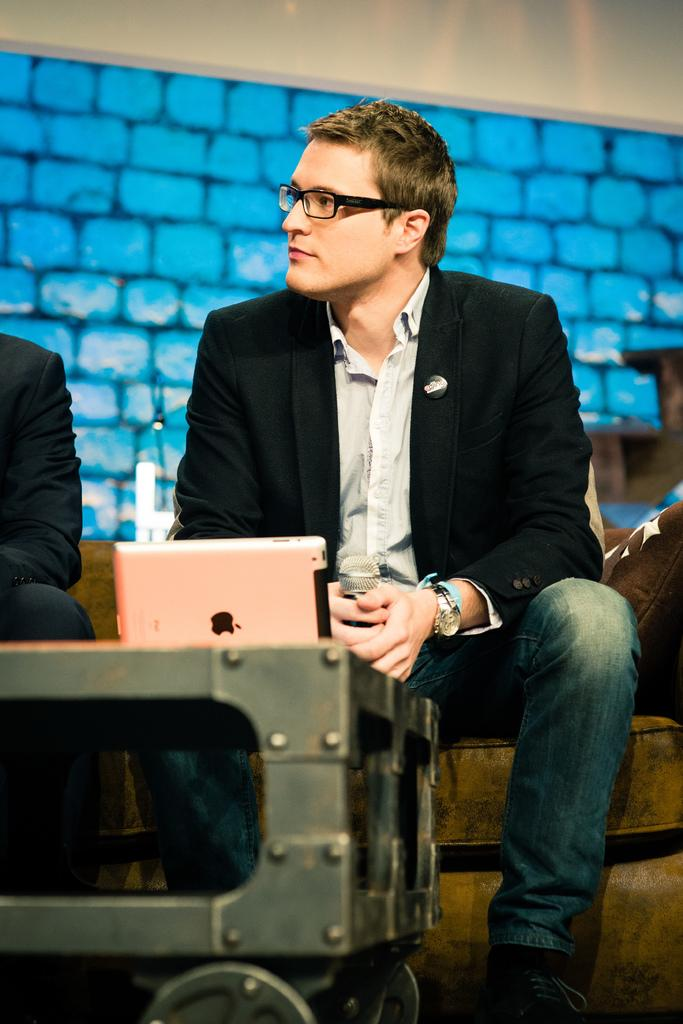How many people are sitting on the couch in the image? There are two people sitting on the couch in the image. What can be seen on the couch besides the people? There are pillows on the couch. What is the man holding in the image? One man is holding a microphone. What type of electronic device is on the table in the image? There is an Apple device on a table. What type of bird is flying over the couch in the image? There is no bird present in the image; it only features two people sitting on a couch, pillows, a microphone, and an Apple device on a table. 